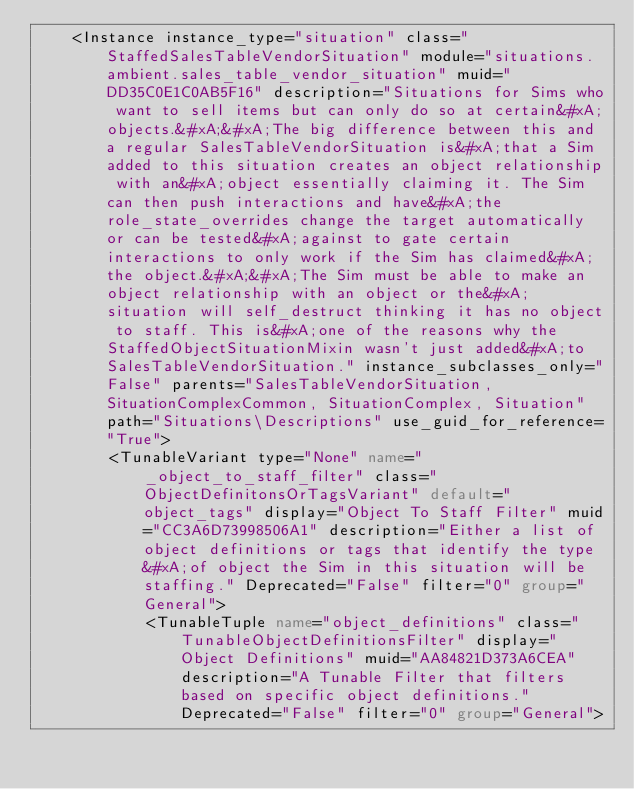Convert code to text. <code><loc_0><loc_0><loc_500><loc_500><_XML_>    <Instance instance_type="situation" class="StaffedSalesTableVendorSituation" module="situations.ambient.sales_table_vendor_situation" muid="DD35C0E1C0AB5F16" description="Situations for Sims who want to sell items but can only do so at certain&#xA;objects.&#xA;&#xA;The big difference between this and a regular SalesTableVendorSituation is&#xA;that a Sim added to this situation creates an object relationship with an&#xA;object essentially claiming it. The Sim can then push interactions and have&#xA;the role_state_overrides change the target automatically or can be tested&#xA;against to gate certain interactions to only work if the Sim has claimed&#xA;the object.&#xA;&#xA;The Sim must be able to make an object relationship with an object or the&#xA;situation will self_destruct thinking it has no object to staff. This is&#xA;one of the reasons why the StaffedObjectSituationMixin wasn't just added&#xA;to SalesTableVendorSituation." instance_subclasses_only="False" parents="SalesTableVendorSituation, SituationComplexCommon, SituationComplex, Situation" path="Situations\Descriptions" use_guid_for_reference="True">
        <TunableVariant type="None" name="_object_to_staff_filter" class="ObjectDefinitonsOrTagsVariant" default="object_tags" display="Object To Staff Filter" muid="CC3A6D73998506A1" description="Either a list of object definitions or tags that identify the type&#xA;of object the Sim in this situation will be staffing." Deprecated="False" filter="0" group="General">
            <TunableTuple name="object_definitions" class="TunableObjectDefinitionsFilter" display="Object Definitions" muid="AA84821D373A6CEA" description="A Tunable Filter that filters based on specific object definitions." Deprecated="False" filter="0" group="General"></code> 